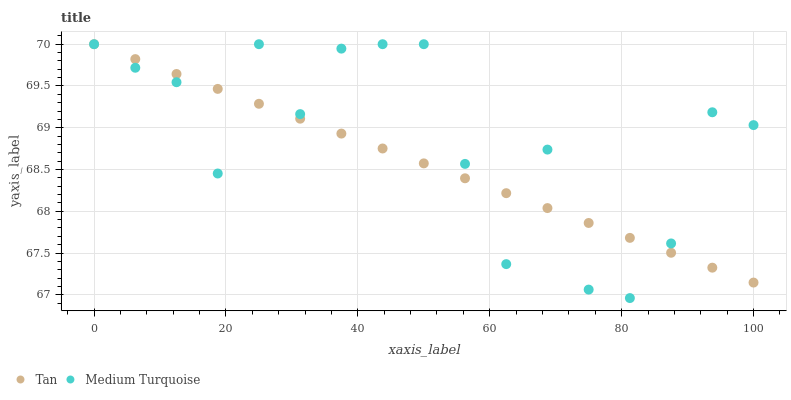Does Tan have the minimum area under the curve?
Answer yes or no. Yes. Does Medium Turquoise have the maximum area under the curve?
Answer yes or no. Yes. Does Medium Turquoise have the minimum area under the curve?
Answer yes or no. No. Is Tan the smoothest?
Answer yes or no. Yes. Is Medium Turquoise the roughest?
Answer yes or no. Yes. Is Medium Turquoise the smoothest?
Answer yes or no. No. Does Medium Turquoise have the lowest value?
Answer yes or no. Yes. Does Medium Turquoise have the highest value?
Answer yes or no. Yes. Does Tan intersect Medium Turquoise?
Answer yes or no. Yes. Is Tan less than Medium Turquoise?
Answer yes or no. No. Is Tan greater than Medium Turquoise?
Answer yes or no. No. 